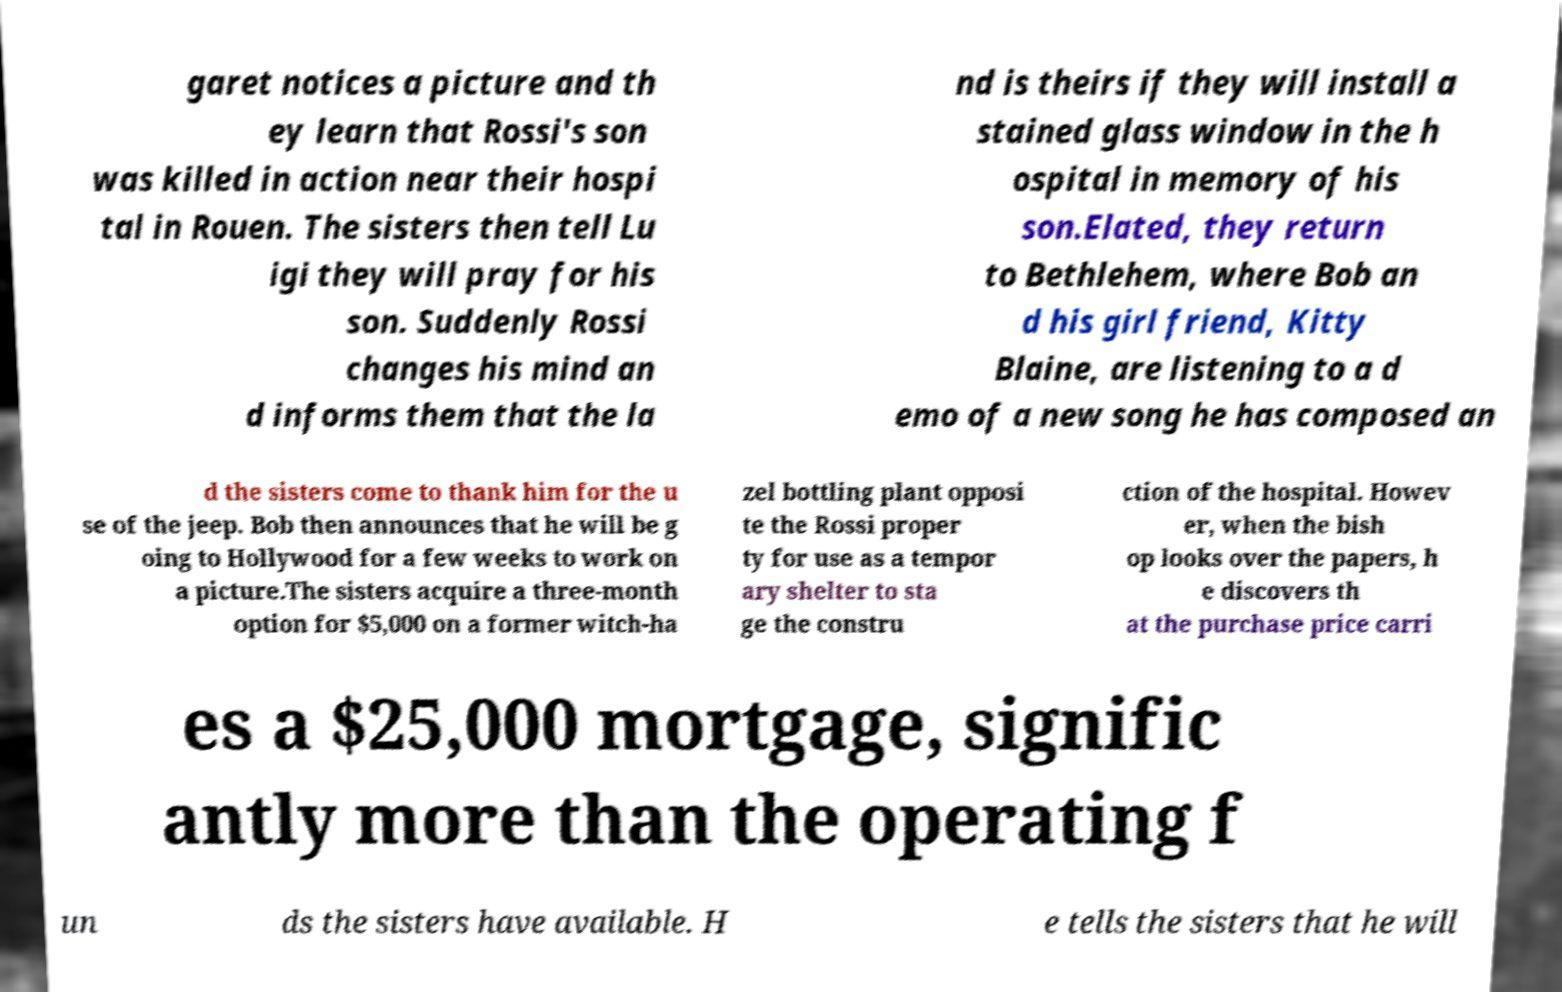Please read and relay the text visible in this image. What does it say? garet notices a picture and th ey learn that Rossi's son was killed in action near their hospi tal in Rouen. The sisters then tell Lu igi they will pray for his son. Suddenly Rossi changes his mind an d informs them that the la nd is theirs if they will install a stained glass window in the h ospital in memory of his son.Elated, they return to Bethlehem, where Bob an d his girl friend, Kitty Blaine, are listening to a d emo of a new song he has composed an d the sisters come to thank him for the u se of the jeep. Bob then announces that he will be g oing to Hollywood for a few weeks to work on a picture.The sisters acquire a three-month option for $5,000 on a former witch-ha zel bottling plant opposi te the Rossi proper ty for use as a tempor ary shelter to sta ge the constru ction of the hospital. Howev er, when the bish op looks over the papers, h e discovers th at the purchase price carri es a $25,000 mortgage, signific antly more than the operating f un ds the sisters have available. H e tells the sisters that he will 